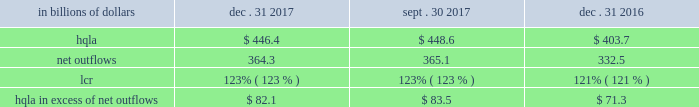Liquidity monitoring and measurement stress testing liquidity stress testing is performed for each of citi 2019s major entities , operating subsidiaries and/or countries .
Stress testing and scenario analyses are intended to quantify the potential impact of an adverse liquidity event on the balance sheet and liquidity position , and to identify viable funding alternatives that can be utilized .
These scenarios include assumptions about significant changes in key funding sources , market triggers ( such as credit ratings ) , potential uses of funding and geopolitical and macroeconomic conditions .
These conditions include expected and stressed market conditions as well as company-specific events .
Liquidity stress tests are conducted to ascertain potential mismatches between liquidity sources and uses over a variety of time horizons and over different stressed conditions .
Liquidity limits are set accordingly .
To monitor the liquidity of an entity , these stress tests and potential mismatches are calculated with varying frequencies , with several tests performed daily .
Given the range of potential stresses , citi maintains contingency funding plans on a consolidated basis and for individual entities .
These plans specify a wide range of readily available actions for a variety of adverse market conditions or idiosyncratic stresses .
Short-term liquidity measurement : liquidity coverage ratio ( lcr ) in addition to internal liquidity stress metrics that citi has developed for a 30-day stress scenario , citi also monitors its liquidity by reference to the lcr , as calculated pursuant to the u.s .
Lcr rules .
Generally , the lcr is designed to ensure that banks maintain an adequate level of hqla to meet liquidity needs under an acute 30-day stress scenario .
The lcr is calculated by dividing hqla by estimated net outflows over a stressed 30-day period , with the net outflows determined by applying prescribed outflow factors to various categories of liabilities , such as deposits , unsecured and secured wholesale borrowings , unused lending commitments and derivatives- related exposures , partially offset by inflows from assets maturing within 30 days .
Banks are required to calculate an add-on to address potential maturity mismatches between contractual cash outflows and inflows within the 30-day period in determining the total amount of net outflows .
The minimum lcr requirement is 100% ( 100 % ) , effective january 2017 .
Pursuant to the federal reserve board 2019s final rule regarding lcr disclosures , effective april 1 , 2017 , citi began to disclose lcr in the prescribed format .
The table below sets forth the components of citi 2019s lcr calculation and hqla in excess of net outflows for the periods indicated : in billions of dollars dec .
31 , sept .
30 , dec .
31 .
Note : amounts set forth in the table above are presented on an average basis .
As set forth in the table above , citi 2019s lcr increased year- over-year , as the increase in the hqla ( as discussed above ) more than offset an increase in modeled net outflows .
The increase in modeled net outflows was primarily driven by changes in assumptions , including changes in methodology to better align citi 2019s outflow assumptions with those embedded in its resolution planning .
Sequentially , citi 2019s lcr remained unchanged .
Long-term liquidity measurement : net stable funding ratio ( nsfr ) in 2016 , the federal reserve board , the fdic and the occ issued a proposed rule to implement the basel iii nsfr requirement .
The u.s.-proposed nsfr is largely consistent with the basel committee 2019s final nsfr rules .
In general , the nsfr assesses the availability of a bank 2019s stable funding against a required level .
A bank 2019s available stable funding would include portions of equity , deposits and long-term debt , while its required stable funding would be based on the liquidity characteristics of its assets , derivatives and commitments .
Prescribed factors would be required to be applied to the various categories of asset and liabilities classes .
The ratio of available stable funding to required stable funding would be required to be greater than 100% ( 100 % ) .
While citi believes that it is compliant with the proposed u.s .
Nsfr rules as of december 31 , 2017 , it will need to evaluate a final version of the rules , which are expected to be released during 2018 .
Citi expects that the nsfr final rules implementation period will be communicated along with the final version of the rules. .
What was the change in billions of hqla from dec . 31 , 2016 to dec . 31 , 2017? 
Computations: (446.4 - 403.7)
Answer: 42.7. 